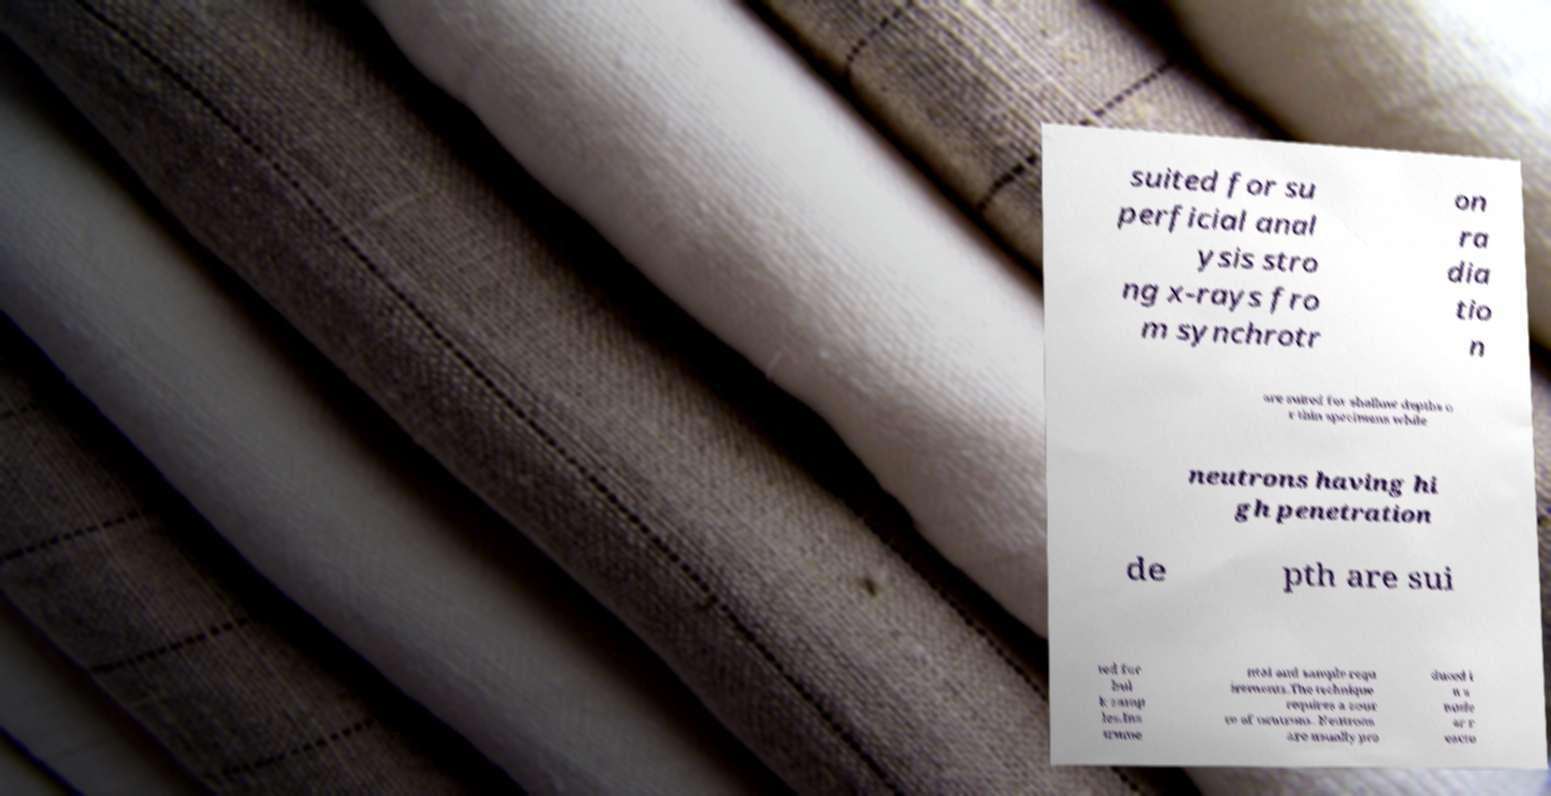Please read and relay the text visible in this image. What does it say? suited for su perficial anal ysis stro ng x-rays fro m synchrotr on ra dia tio n are suited for shallow depths o r thin specimens while neutrons having hi gh penetration de pth are sui ted for bul k samp les.Ins trume ntal and sample requ irements.The technique requires a sour ce of neutrons. Neutrons are usually pro duced i n a nucle ar r eacto 